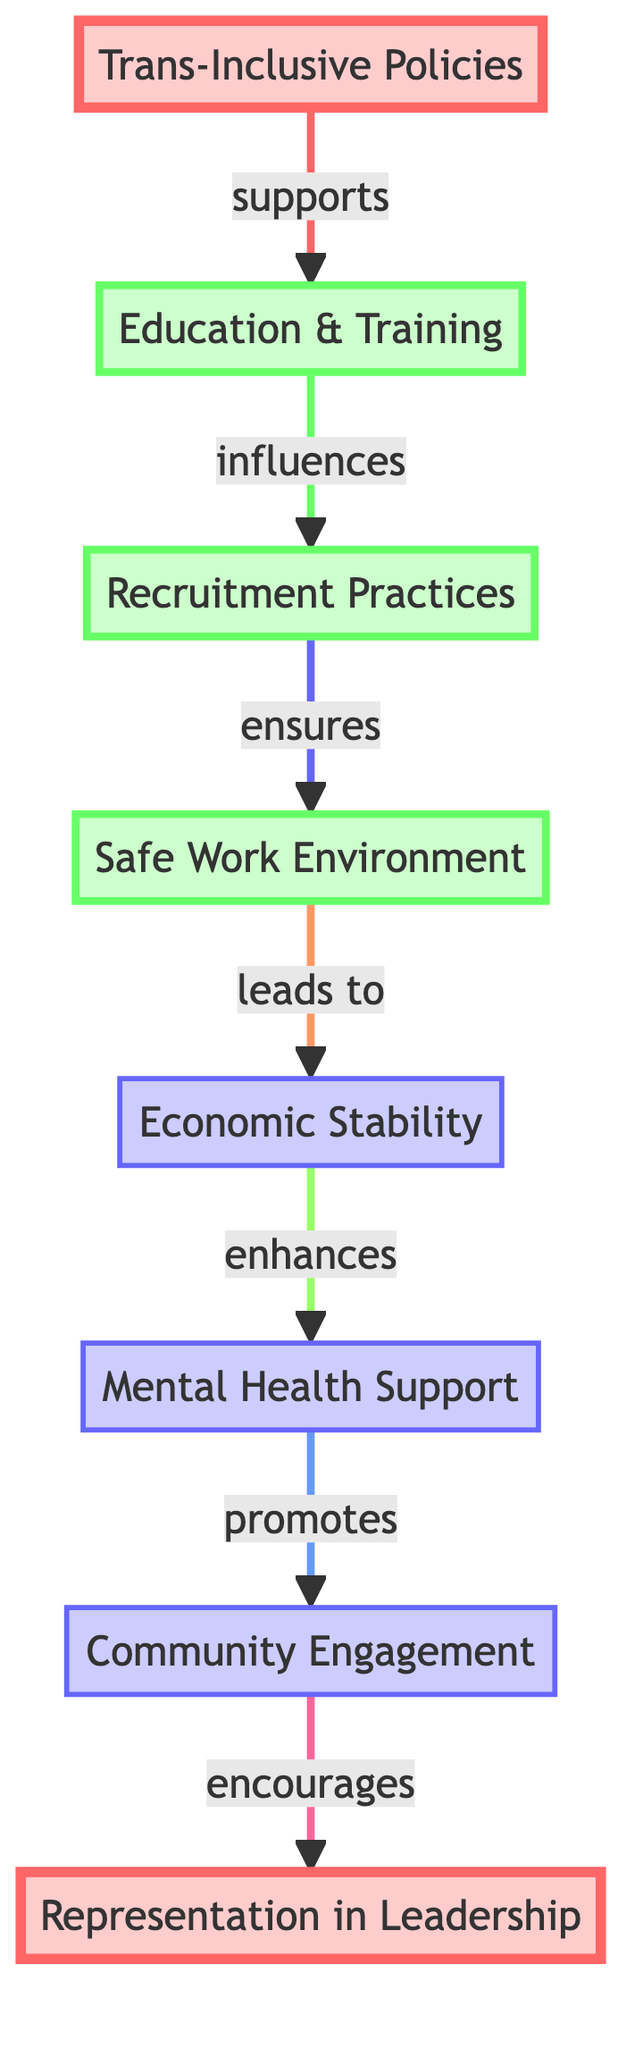What is the first node in the diagram? The diagram starts with the node labeled "Trans-Inclusive Policies," which is the first step in the food chain.
Answer: Trans-Inclusive Policies How many nodes are there in total? The diagram has a total of eight nodes, counting from "Trans-Inclusive Policies" to "Representation in Leadership."
Answer: 8 What node leads to "Safe Work Environment"? The node that leads to "Safe Work Environment" is "Recruitment Practices." This relationship shows that recruitment practices ensure a safe work environment.
Answer: Recruitment Practices Which node is directly influenced by "Education & Training"? "Recruitment Practices" is directly influenced by "Education & Training," signifying the strong link between training and recruitment strategies.
Answer: Recruitment Practices What is the last node in the diagram? The last node in the diagram is "Representation in Leadership," which represents the end outcome of the flow chain.
Answer: Representation in Leadership How does "Economic Stability" relate to "Mental Health Support"? "Economic Stability" enhances "Mental Health Support," indicating that stable economic conditions improve mental health resources and support.
Answer: enhances Which nodes are in level 1 of the diagram? The nodes in level 1 are "Trans-Inclusive Policies" and "Representation in Leadership," which are marked with distinctive coloring in the diagram.
Answer: Trans-Inclusive Policies, Representation in Leadership What is the sequence from "Trans-Inclusive Policies" to "Economic Stability"? The sequence is: Trans-Inclusive Policies → Education & Training → Recruitment Practices → Safe Work Environment → Economic Stability, showing the progression through the chain.
Answer: Trans-Inclusive Policies → Education & Training → Recruitment Practices → Safe Work Environment → Economic Stability Which node has the most connections? The node "Education & Training" has the most connections as it influences "Recruitment Practices," which in turn affects "Safe Work Environment" and leads to "Economic Stability."
Answer: Education & Training 